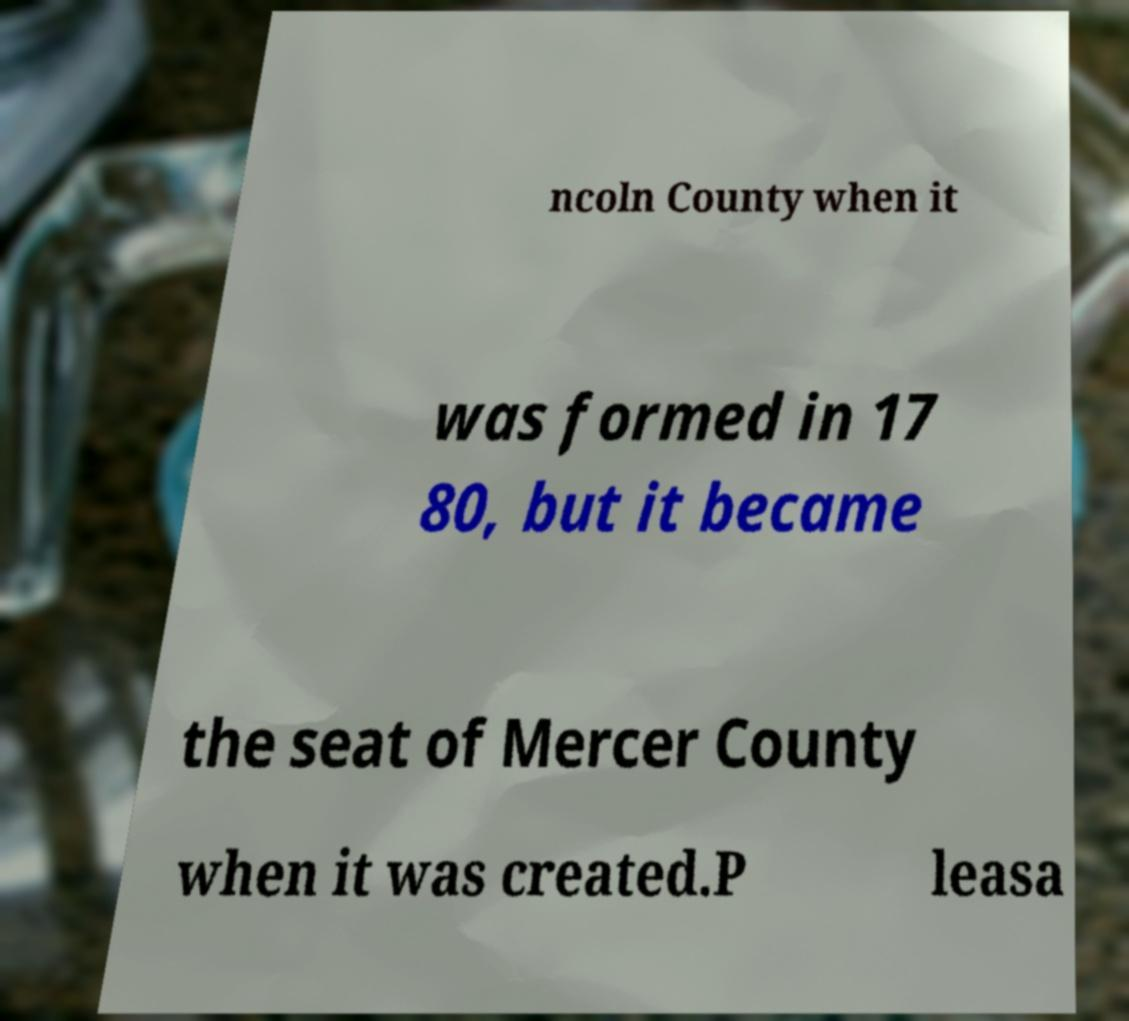Could you assist in decoding the text presented in this image and type it out clearly? ncoln County when it was formed in 17 80, but it became the seat of Mercer County when it was created.P leasa 